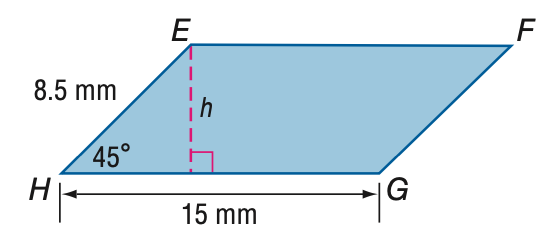Answer the mathemtical geometry problem and directly provide the correct option letter.
Question: Find the area of \parallelogram E F G H.
Choices: A: 64 B: 90 C: 110 D: 127 B 